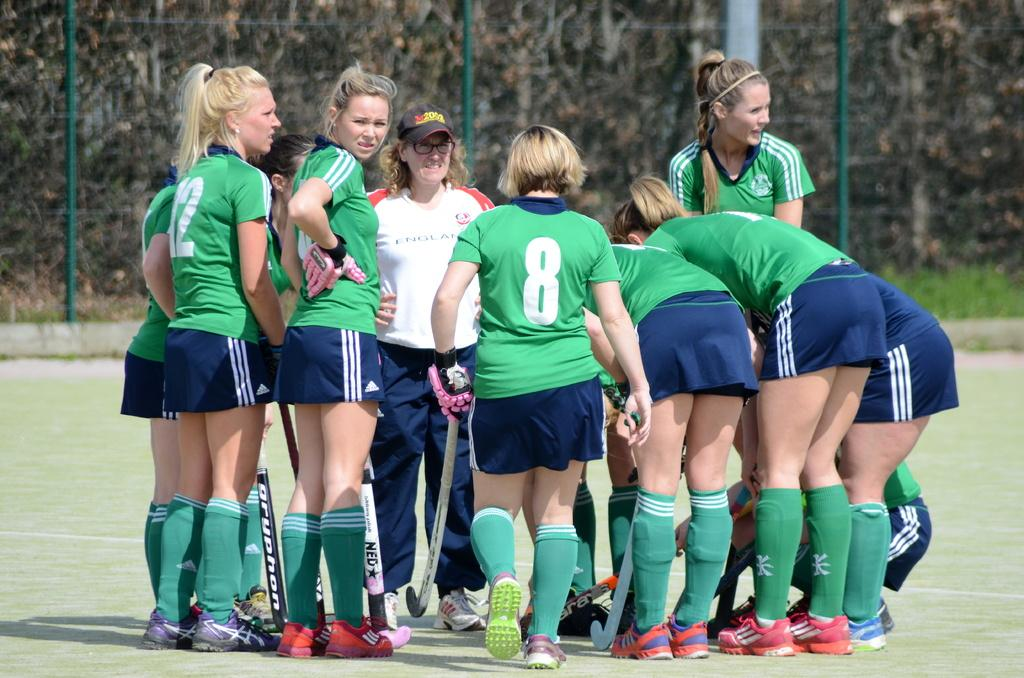<image>
Render a clear and concise summary of the photo. Several athletes are together, one having an "8" on her shirt. 